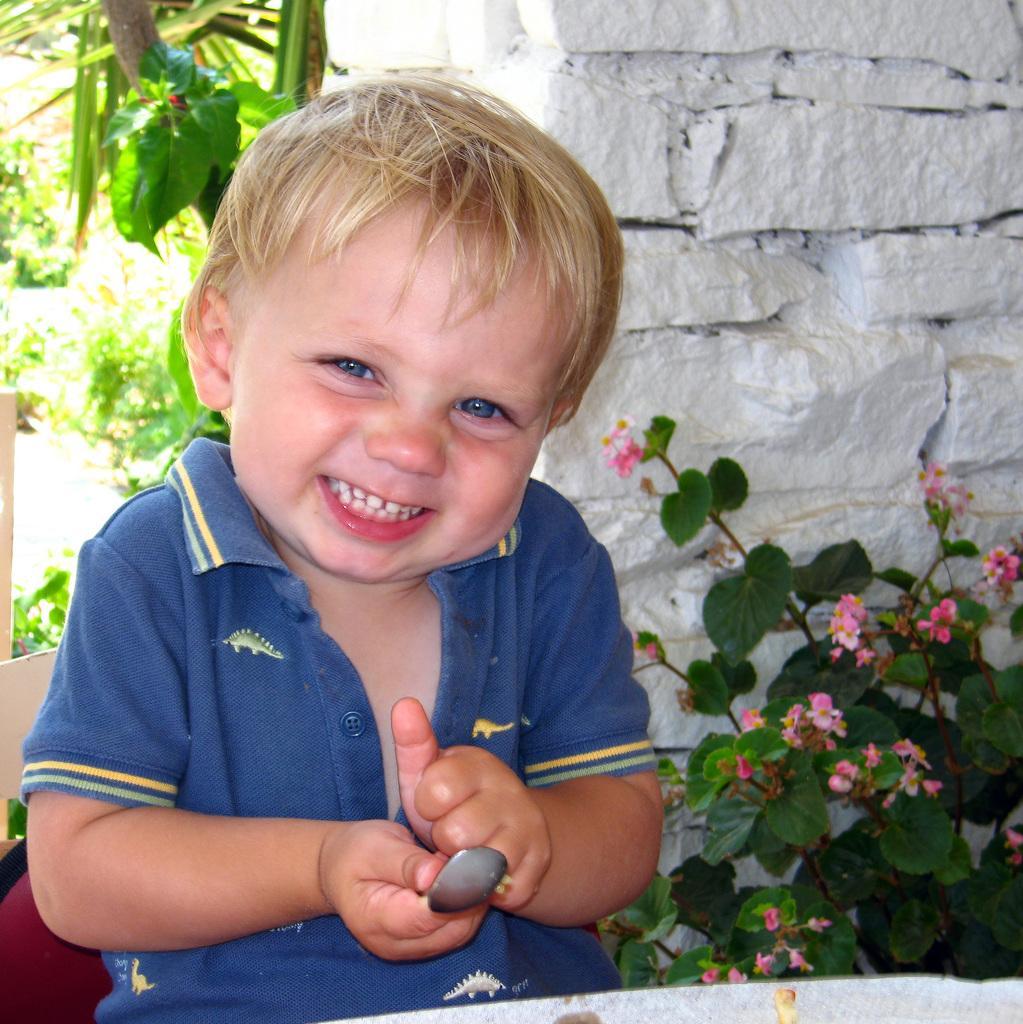Describe this image in one or two sentences. In the image we can see a baby on the left side of the image, the baby is wearing clothes and holding spoon in hand and the baby is smiling. Here we can see the flower plant, stone wall and the leaves. 